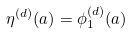<formula> <loc_0><loc_0><loc_500><loc_500>\eta ^ { ( d ) } ( a ) = \phi _ { 1 } ^ { ( d ) } ( a )</formula> 